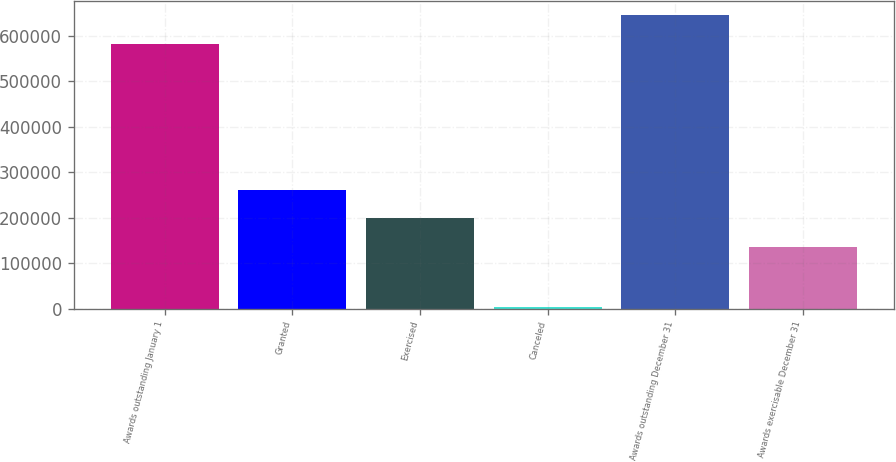Convert chart. <chart><loc_0><loc_0><loc_500><loc_500><bar_chart><fcel>Awards outstanding January 1<fcel>Granted<fcel>Exercised<fcel>Canceled<fcel>Awards outstanding December 31<fcel>Awards exercisable December 31<nl><fcel>581694<fcel>261270<fcel>198787<fcel>3500<fcel>644177<fcel>136304<nl></chart> 